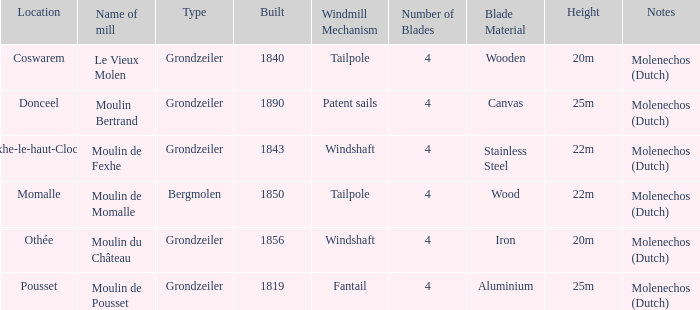What is the Name of the Grondzeiler Mill? Le Vieux Molen, Moulin Bertrand, Moulin de Fexhe, Moulin du Château, Moulin de Pousset. Could you parse the entire table? {'header': ['Location', 'Name of mill', 'Type', 'Built', 'Windmill Mechanism', 'Number of Blades', 'Blade Material', 'Height', 'Notes'], 'rows': [['Coswarem', 'Le Vieux Molen', 'Grondzeiler', '1840', 'Tailpole', '4', 'Wooden', '20m', 'Molenechos (Dutch)'], ['Donceel', 'Moulin Bertrand', 'Grondzeiler', '1890', 'Patent sails', '4', 'Canvas', '25m', 'Molenechos (Dutch)'], ['Fexhe-le-haut-Clocher', 'Moulin de Fexhe', 'Grondzeiler', '1843', 'Windshaft', '4', 'Stainless Steel', '22m', 'Molenechos (Dutch)'], ['Momalle', 'Moulin de Momalle', 'Bergmolen', '1850', 'Tailpole', '4', 'Wood', '22m', 'Molenechos (Dutch)'], ['Othée', 'Moulin du Château', 'Grondzeiler', '1856', 'Windshaft', '4', 'Iron', '20m', 'Molenechos (Dutch)'], ['Pousset', 'Moulin de Pousset', 'Grondzeiler', '1819', 'Fantail', '4', 'Aluminium', '25m', 'Molenechos (Dutch)']]} 